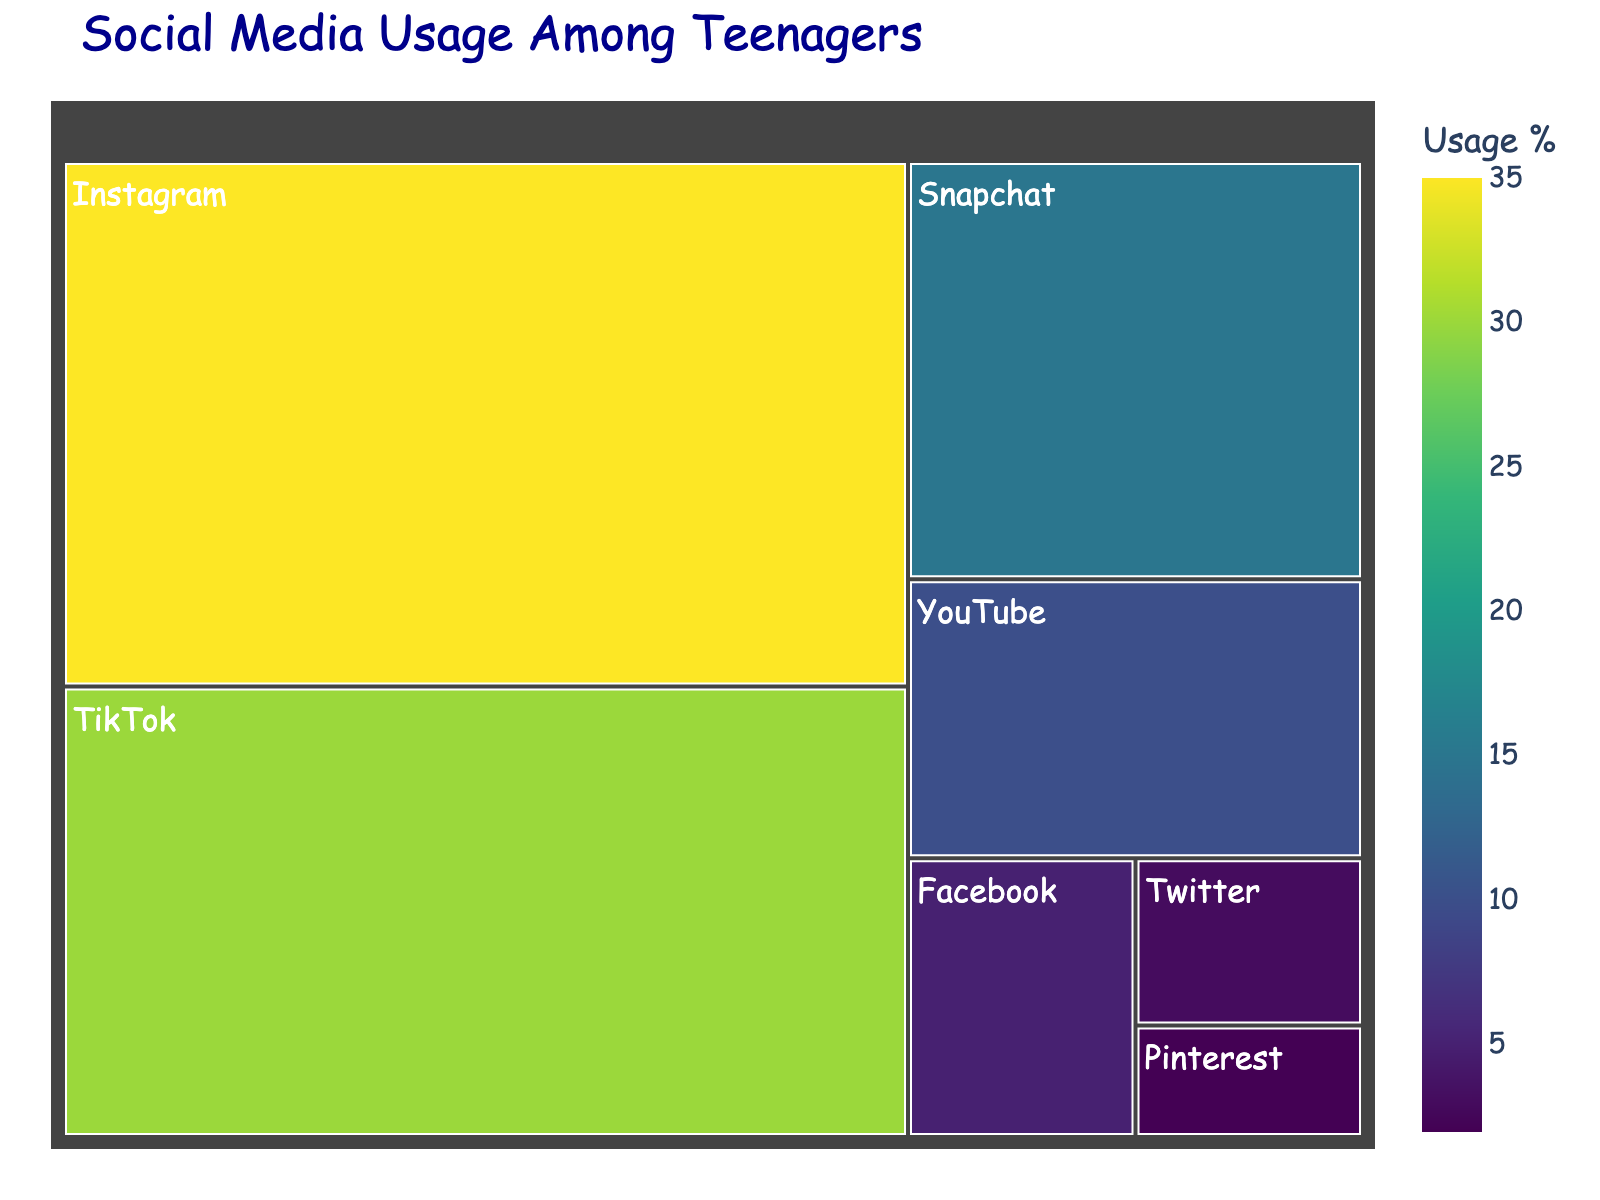What's the title of the treemap? The title is usually shown at the top of the figure and summarizes the main topic being visualized. Here, the title given in the code is "Social Media Usage Among Teenagers".
Answer: Social Media Usage Among Teenagers Which platform has the highest usage among teenagers? Look at the platform with the largest area and highest percentage in the figure. Instagram has the largest section with a usage percentage of 35%.
Answer: Instagram How many platforms have a usage percentage of less than 10%? Identify the sections with usage values less than 10% and count them. YouTube, Facebook, Twitter, and Pinterest fall under this category, making it four platforms.
Answer: 4 What is the combined usage percentage of TikTok and Snapchat? Add the usage percentages of TikTok and Snapchat together. TikTok has 30% usage and Snapchat has 15%, so the combined usage is 30% + 15% = 45%.
Answer: 45% Which color scale is used to represent the usage percentages? The color scale used can be inferred from the color scheme visible in the treemap. The `color_continuous_scale` parameter of the code reveals it is 'Viridis'. However, the answer should reflect observable properties, not the coding term. The colors range from dark blue to bright yellow, typical of the Viridis color scale.
Answer: Viridis What is the total usage percentage represented in the treemap? The total usage percentage can be found by summing the usage percentages of all platforms listed in the figure. Adding them gives 35%+30%+15%+10%+5%+3%+2% = 100%.
Answer: 100% Which platform has the smallest representation in the treemap? Look for the smallest area in the treemap, which corresponds to the lowest usage percentage. Pinterest, with 2% usage, is the smallest.
Answer: Pinterest Compare the usage between Facebook and Twitter. Which one has higher usage and by how much? Identify Facebook and Twitter's usage percentages from the treemap, which are 5% and 3%, respectively. Subtract Twitter's usage from Facebook's usage: 5% - 3% = 2%. Facebook has 2% higher usage.
Answer: Facebook, by 2% How does YouTube's usage compare to the total of Facebook and Twitter's usage together? Add Facebook and Twitter's usage percentages then compare with YouTube's. Facebook and Twitter together have 5% + 3% = 8%, while YouTube has 10%. YouTube's usage is higher by 10% - 8% = 2%.
Answer: Higher, by 2% What does each color intensity in the treemap indicate? The color intensity represents the usage percentage, with deeper colors indicating higher usage based on the Viridis color scale used. For instance, Instagram has the deepest color since it has the highest usage at 35%.
Answer: Usage percentage 